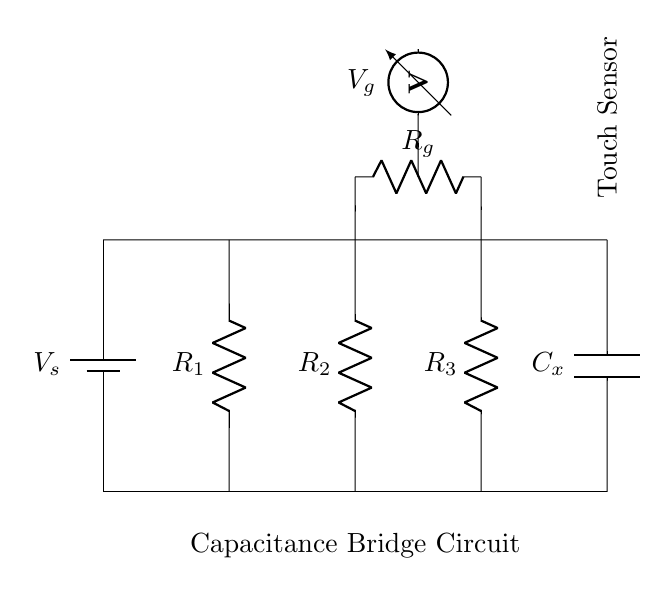What is the total number of resistors in this circuit? There are three resistors present in the circuit, as represented by the labels R1, R2, and R3 connected in series between the voltage source and the capacitor.
Answer: 3 What component is connected to the voltage source? The component connected to the voltage source is a resistor labeled R1. It is the first connection from the top of the circuit diagram, indicating that it receives the voltage V_s.
Answer: Resistor R1 What is the purpose of the capacitance bridge circuit? The purpose of the capacitance bridge circuit is to measure the capacitance (C_x) of the touch sensor by balancing it against known values in a ratio. This allows for precise capacitance measurements, crucial for touch-sensitive applications.
Answer: Measure capacitance What is the value of the voltmeter output labeled V_g? The value of V_g is not explicitly given in the circuit diagram; however, it indicates the voltage measured across the resistor R_g, which provides insights into the balance of the circuit. The exact voltage would depend on the values of other components and the total voltage applied.
Answer: Not specified How does the touch sensor relate to the rest of the circuit? The touch sensor, represented in the circuit diagram, is connected to the capacitor C_x, which means it is directly influenced by the capacitance measurement determined by the bridge circuit. When touched, it alters the capacitance being measured, allowing for user interaction.
Answer: Connected to C_x What is the function of resistor R_g in this circuit? Resistor R_g serves to create a reference point within the bridge circuit, allowing for the balance condition to be detected. By measuring the voltage across it, one can determine whether the circuit is balanced and thus deduce the value of capacitance C_x by comparing it to standard values.
Answer: Reference resistor What will happen if C_x is equal to the reference capacitance? If C_x is equal to the reference capacitance, the bridge circuit will be balanced, leading to zero voltage across the voltmeter V_g. This indicates that the conditions for balance are met, verifying that the touched capacitance equals the set reference.
Answer: Zero voltage 